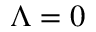Convert formula to latex. <formula><loc_0><loc_0><loc_500><loc_500>\Lambda = 0</formula> 